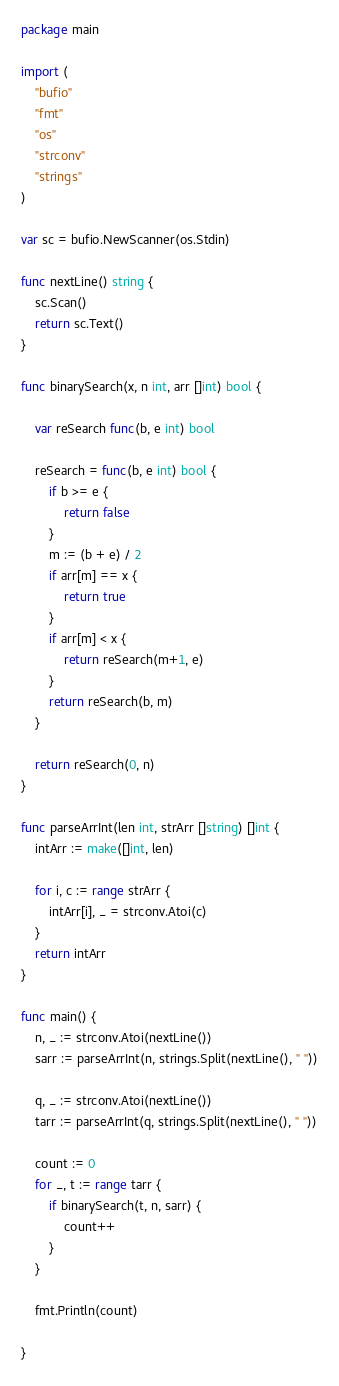<code> <loc_0><loc_0><loc_500><loc_500><_Go_>package main

import (
	"bufio"
	"fmt"
	"os"
	"strconv"
	"strings"
)

var sc = bufio.NewScanner(os.Stdin)

func nextLine() string {
	sc.Scan()
	return sc.Text()
}

func binarySearch(x, n int, arr []int) bool {

	var reSearch func(b, e int) bool

	reSearch = func(b, e int) bool {
		if b >= e {
			return false
		}
		m := (b + e) / 2
		if arr[m] == x {
			return true
		}
		if arr[m] < x {
			return reSearch(m+1, e)
		}
		return reSearch(b, m)
	}

	return reSearch(0, n)
}

func parseArrInt(len int, strArr []string) []int {
	intArr := make([]int, len)

	for i, c := range strArr {
		intArr[i], _ = strconv.Atoi(c)
	}
	return intArr
}

func main() {
	n, _ := strconv.Atoi(nextLine())
	sarr := parseArrInt(n, strings.Split(nextLine(), " "))

	q, _ := strconv.Atoi(nextLine())
	tarr := parseArrInt(q, strings.Split(nextLine(), " "))

	count := 0
	for _, t := range tarr {
		if binarySearch(t, n, sarr) {
			count++
		}
	}

	fmt.Println(count)

}

</code> 